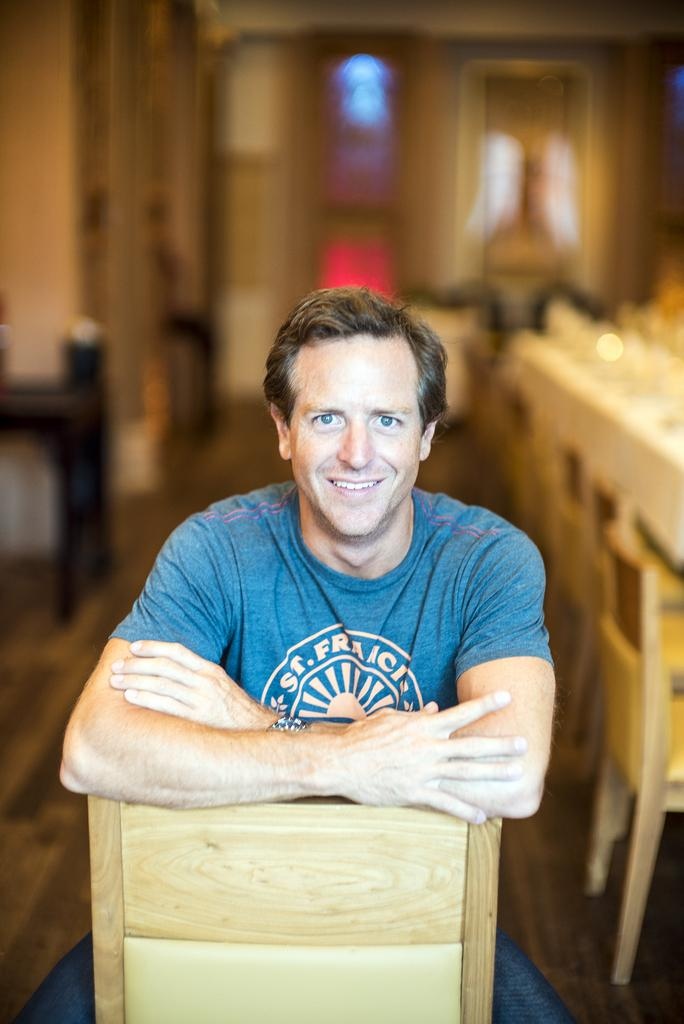What is the person in the image doing? The person is sitting on a chair in the image. What is the person's facial expression? The person is smiling. What can be seen in the background of the image? There is a dining table in the background of the image. On which side of the image is the dining table located? The dining table is on the right side of the image. What word is the person reading from a book in the image? There is no book or word visible in the image; the person is simply sitting and smiling. 